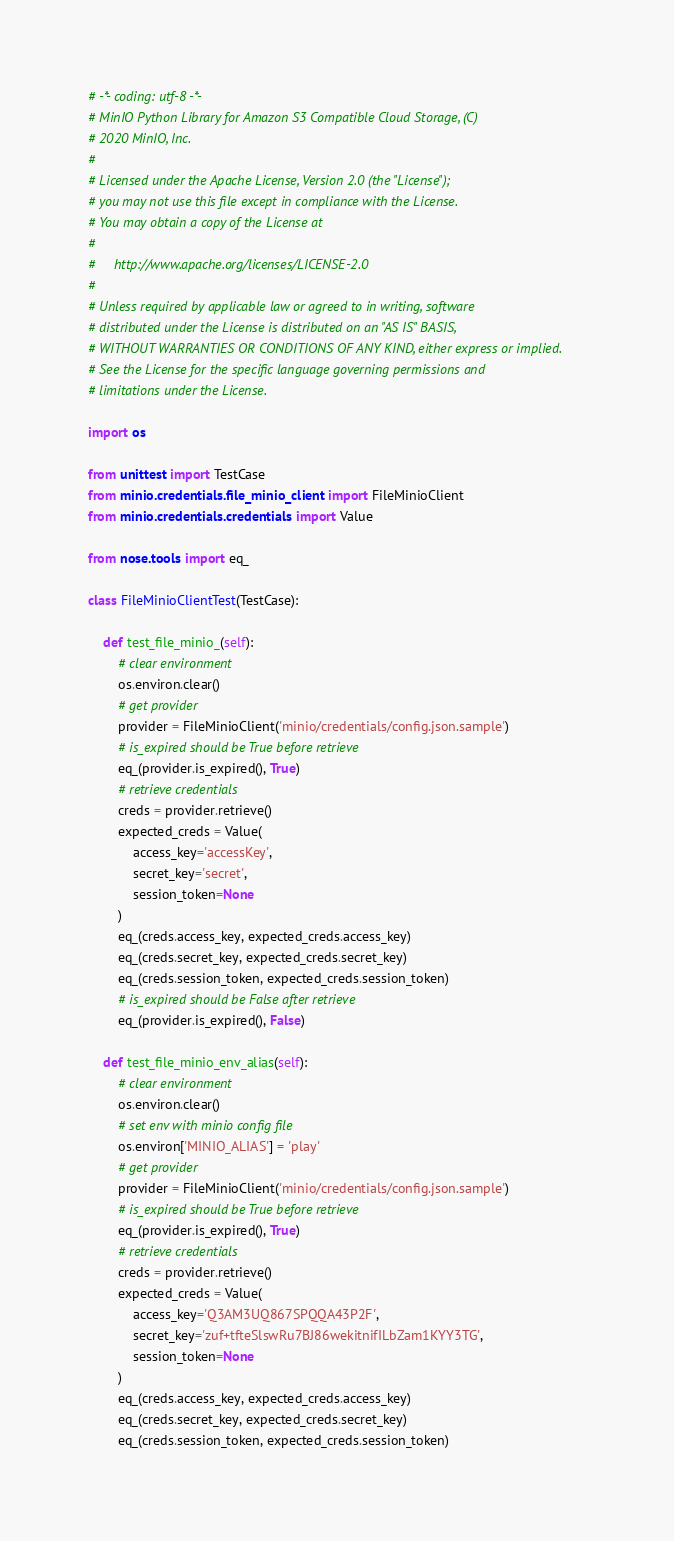<code> <loc_0><loc_0><loc_500><loc_500><_Python_># -*- coding: utf-8 -*-
# MinIO Python Library for Amazon S3 Compatible Cloud Storage, (C)
# 2020 MinIO, Inc.
#
# Licensed under the Apache License, Version 2.0 (the "License");
# you may not use this file except in compliance with the License.
# You may obtain a copy of the License at
#
#     http://www.apache.org/licenses/LICENSE-2.0
#
# Unless required by applicable law or agreed to in writing, software
# distributed under the License is distributed on an "AS IS" BASIS,
# WITHOUT WARRANTIES OR CONDITIONS OF ANY KIND, either express or implied.
# See the License for the specific language governing permissions and
# limitations under the License.

import os

from unittest import TestCase
from minio.credentials.file_minio_client import FileMinioClient
from minio.credentials.credentials import Value

from nose.tools import eq_

class FileMinioClientTest(TestCase):

    def test_file_minio_(self):
        # clear environment
        os.environ.clear()
        # get provider
        provider = FileMinioClient('minio/credentials/config.json.sample')
        # is_expired should be True before retrieve
        eq_(provider.is_expired(), True)
        # retrieve credentials
        creds = provider.retrieve()
        expected_creds = Value(
            access_key='accessKey',
            secret_key='secret',
            session_token=None
        )
        eq_(creds.access_key, expected_creds.access_key)
        eq_(creds.secret_key, expected_creds.secret_key)
        eq_(creds.session_token, expected_creds.session_token)
        # is_expired should be False after retrieve
        eq_(provider.is_expired(), False)

    def test_file_minio_env_alias(self):
        # clear environment
        os.environ.clear()
        # set env with minio config file
        os.environ['MINIO_ALIAS'] = 'play'
        # get provider
        provider = FileMinioClient('minio/credentials/config.json.sample')
        # is_expired should be True before retrieve
        eq_(provider.is_expired(), True)
        # retrieve credentials
        creds = provider.retrieve()
        expected_creds = Value(
            access_key='Q3AM3UQ867SPQQA43P2F',
            secret_key='zuf+tfteSlswRu7BJ86wekitnifILbZam1KYY3TG',
            session_token=None
        )
        eq_(creds.access_key, expected_creds.access_key)
        eq_(creds.secret_key, expected_creds.secret_key)
        eq_(creds.session_token, expected_creds.session_token)</code> 